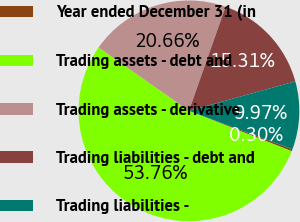<chart> <loc_0><loc_0><loc_500><loc_500><pie_chart><fcel>Year ended December 31 (in<fcel>Trading assets - debt and<fcel>Trading assets - derivative<fcel>Trading liabilities - debt and<fcel>Trading liabilities -<nl><fcel>0.3%<fcel>53.76%<fcel>20.66%<fcel>15.31%<fcel>9.97%<nl></chart> 